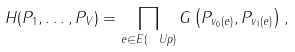<formula> <loc_0><loc_0><loc_500><loc_500>H ( P _ { 1 } , \dots , P _ { V } ) = \prod _ { e \in E ( \ U p ) } G \left ( P _ { v _ { 0 } ( e ) } , P _ { v _ { 1 } ( e ) } \right ) ,</formula> 